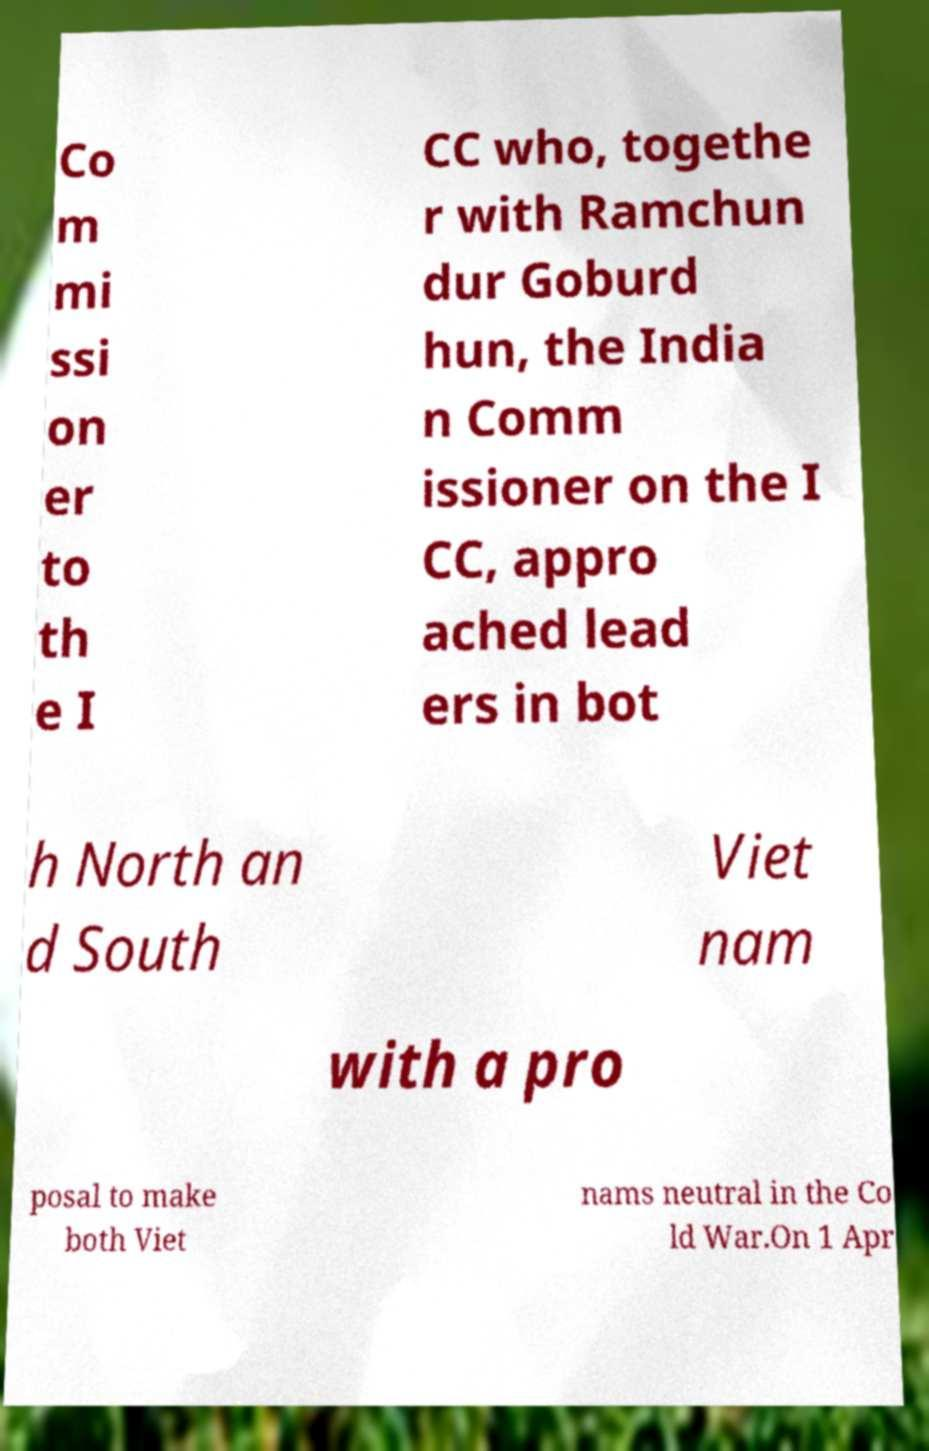Please identify and transcribe the text found in this image. Co m mi ssi on er to th e I CC who, togethe r with Ramchun dur Goburd hun, the India n Comm issioner on the I CC, appro ached lead ers in bot h North an d South Viet nam with a pro posal to make both Viet nams neutral in the Co ld War.On 1 Apr 